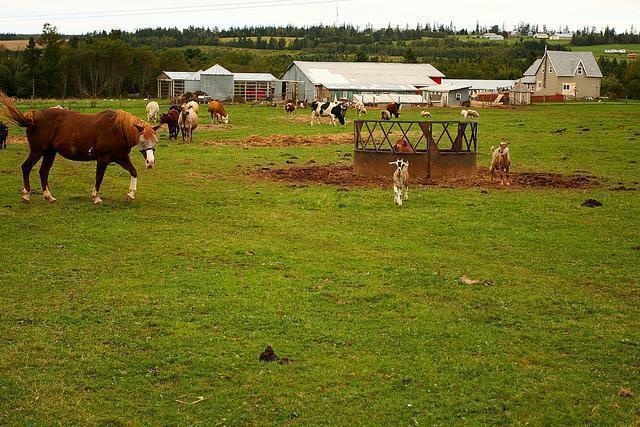How many eyes does the animal on the left have?
Indicate the correct response and explain using: 'Answer: answer
Rationale: rationale.'
Options: Two, eight, three, six. Answer: two.
Rationale: Horses are known for having two eyes as they are mammals. 